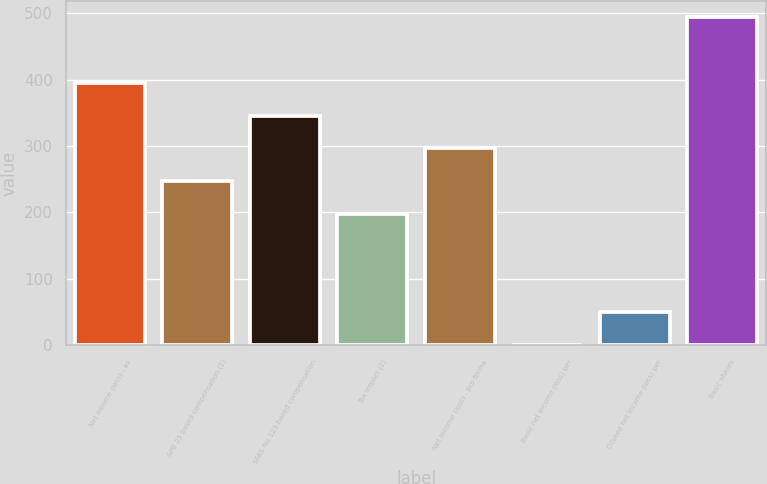Convert chart to OTSL. <chart><loc_0><loc_0><loc_500><loc_500><bar_chart><fcel>Net income (loss) - as<fcel>APB 25 based compensation (2)<fcel>SFAS No 123 based compensation<fcel>Tax impact (2)<fcel>Net income (loss) - pro forma<fcel>Basic net income (loss) per<fcel>Diluted net income (loss) per<fcel>Basic shares<nl><fcel>395.22<fcel>247.11<fcel>345.85<fcel>197.74<fcel>296.48<fcel>0.26<fcel>49.63<fcel>494<nl></chart> 